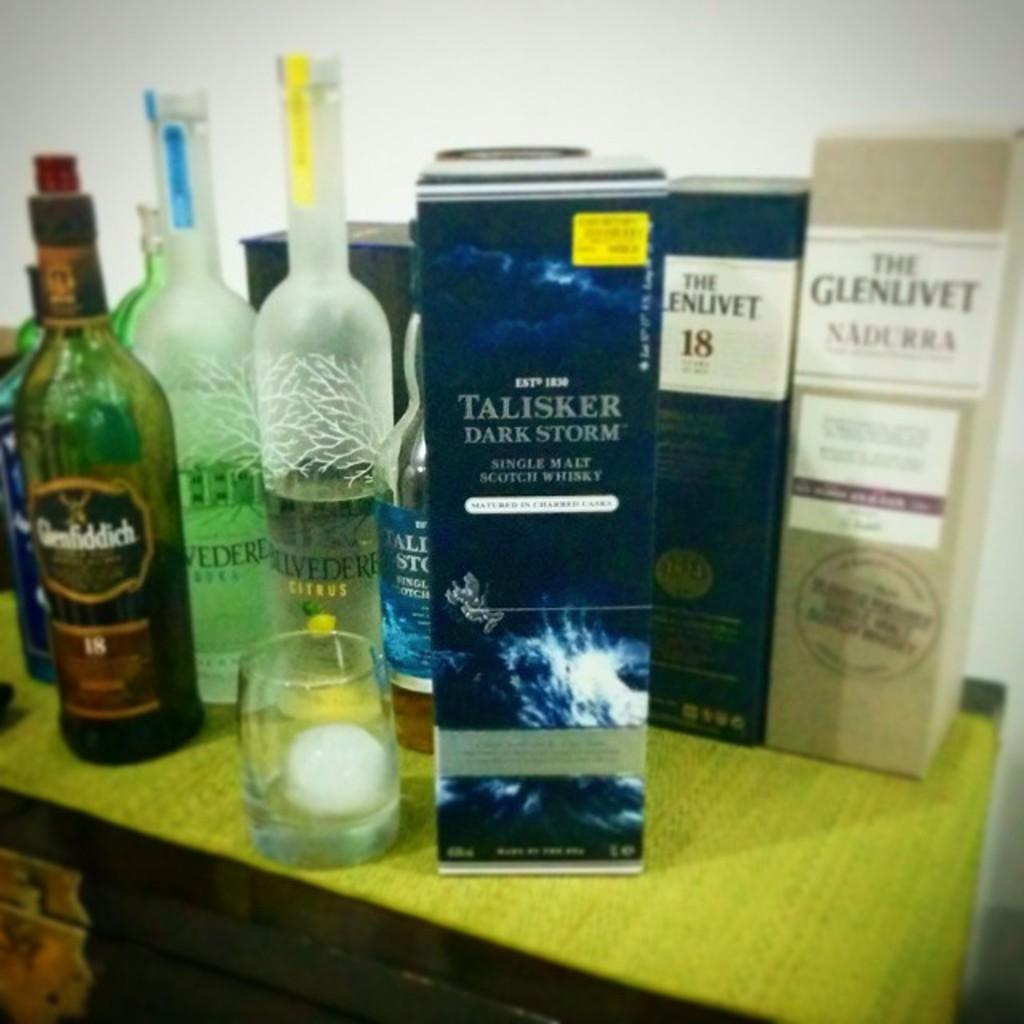<image>
Write a terse but informative summary of the picture. the word talisker that is on the front of a box 